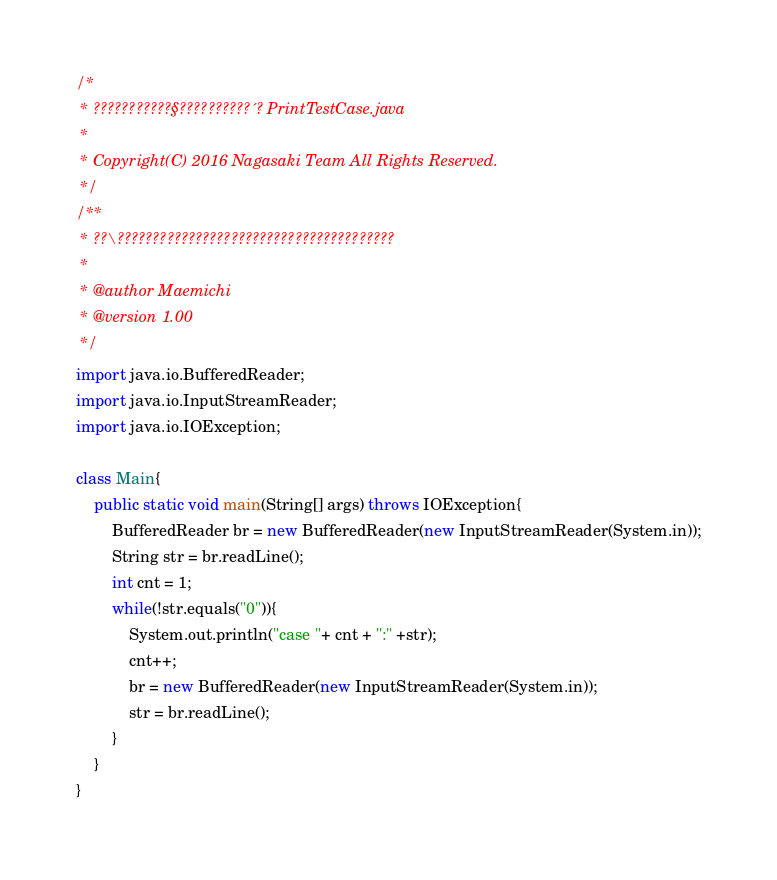Convert code to text. <code><loc_0><loc_0><loc_500><loc_500><_Java_>/* 
 * ???????????§??????????´? PrintTestCase.java
 *
 * Copyright(C) 2016 Nagasaki Team All Rights Reserved.
 */
/**
 * ??\???????????????????????????????????????
 *
 * @author Maemichi
 * @version 1.00
 */
import java.io.BufferedReader;
import java.io.InputStreamReader;
import java.io.IOException;

class Main{
	public static void main(String[] args) throws IOException{
		BufferedReader br = new BufferedReader(new InputStreamReader(System.in));
		String str = br.readLine();
		int cnt = 1;
		while(!str.equals("0")){
			System.out.println("case "+ cnt + ":" +str);
			cnt++;
			br = new BufferedReader(new InputStreamReader(System.in));
			str = br.readLine();
		}
	}
}</code> 